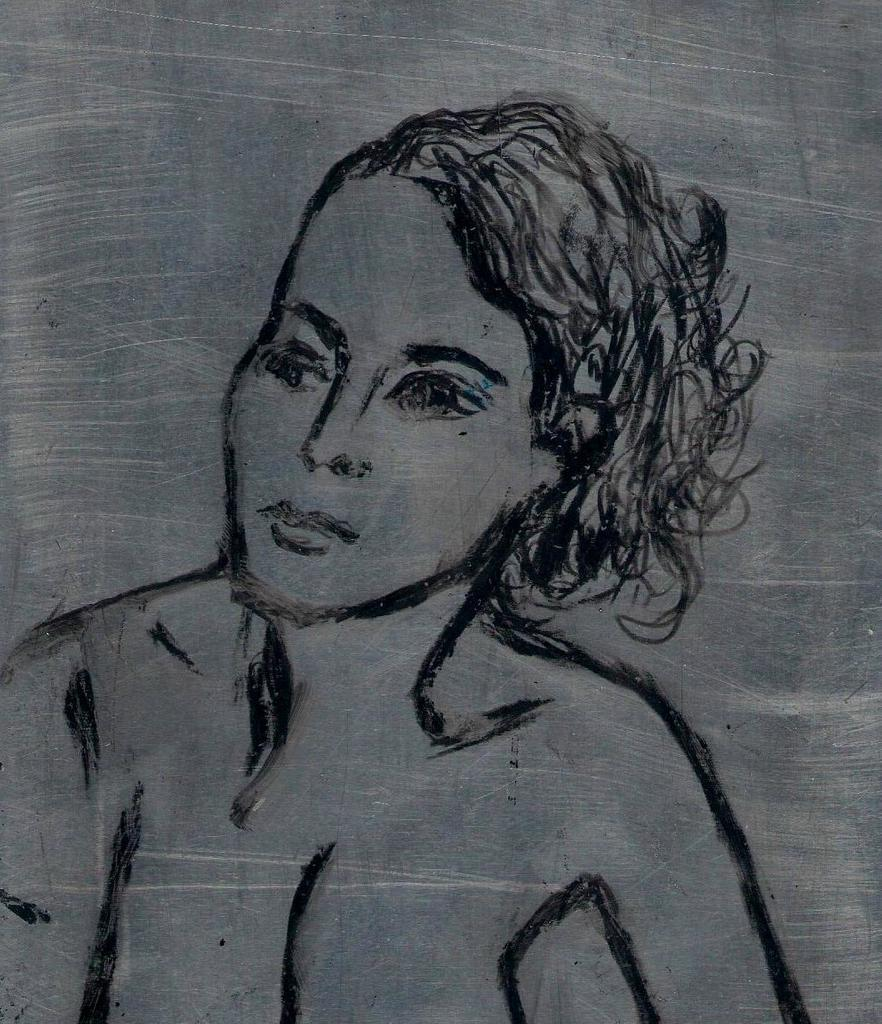What is depicted in the image? There is a sketch of a person in the image. How many rings can be seen on the person's fingers in the image? There is no information about rings or fingers in the image; it only features a sketch of a person. How many bikes are visible in the image? There is no mention of bikes in the image; it only features a sketch of a person. Is there any indication of war or conflict in the image? There is no indication of war or conflict in the image; it only features a sketch of a person. 